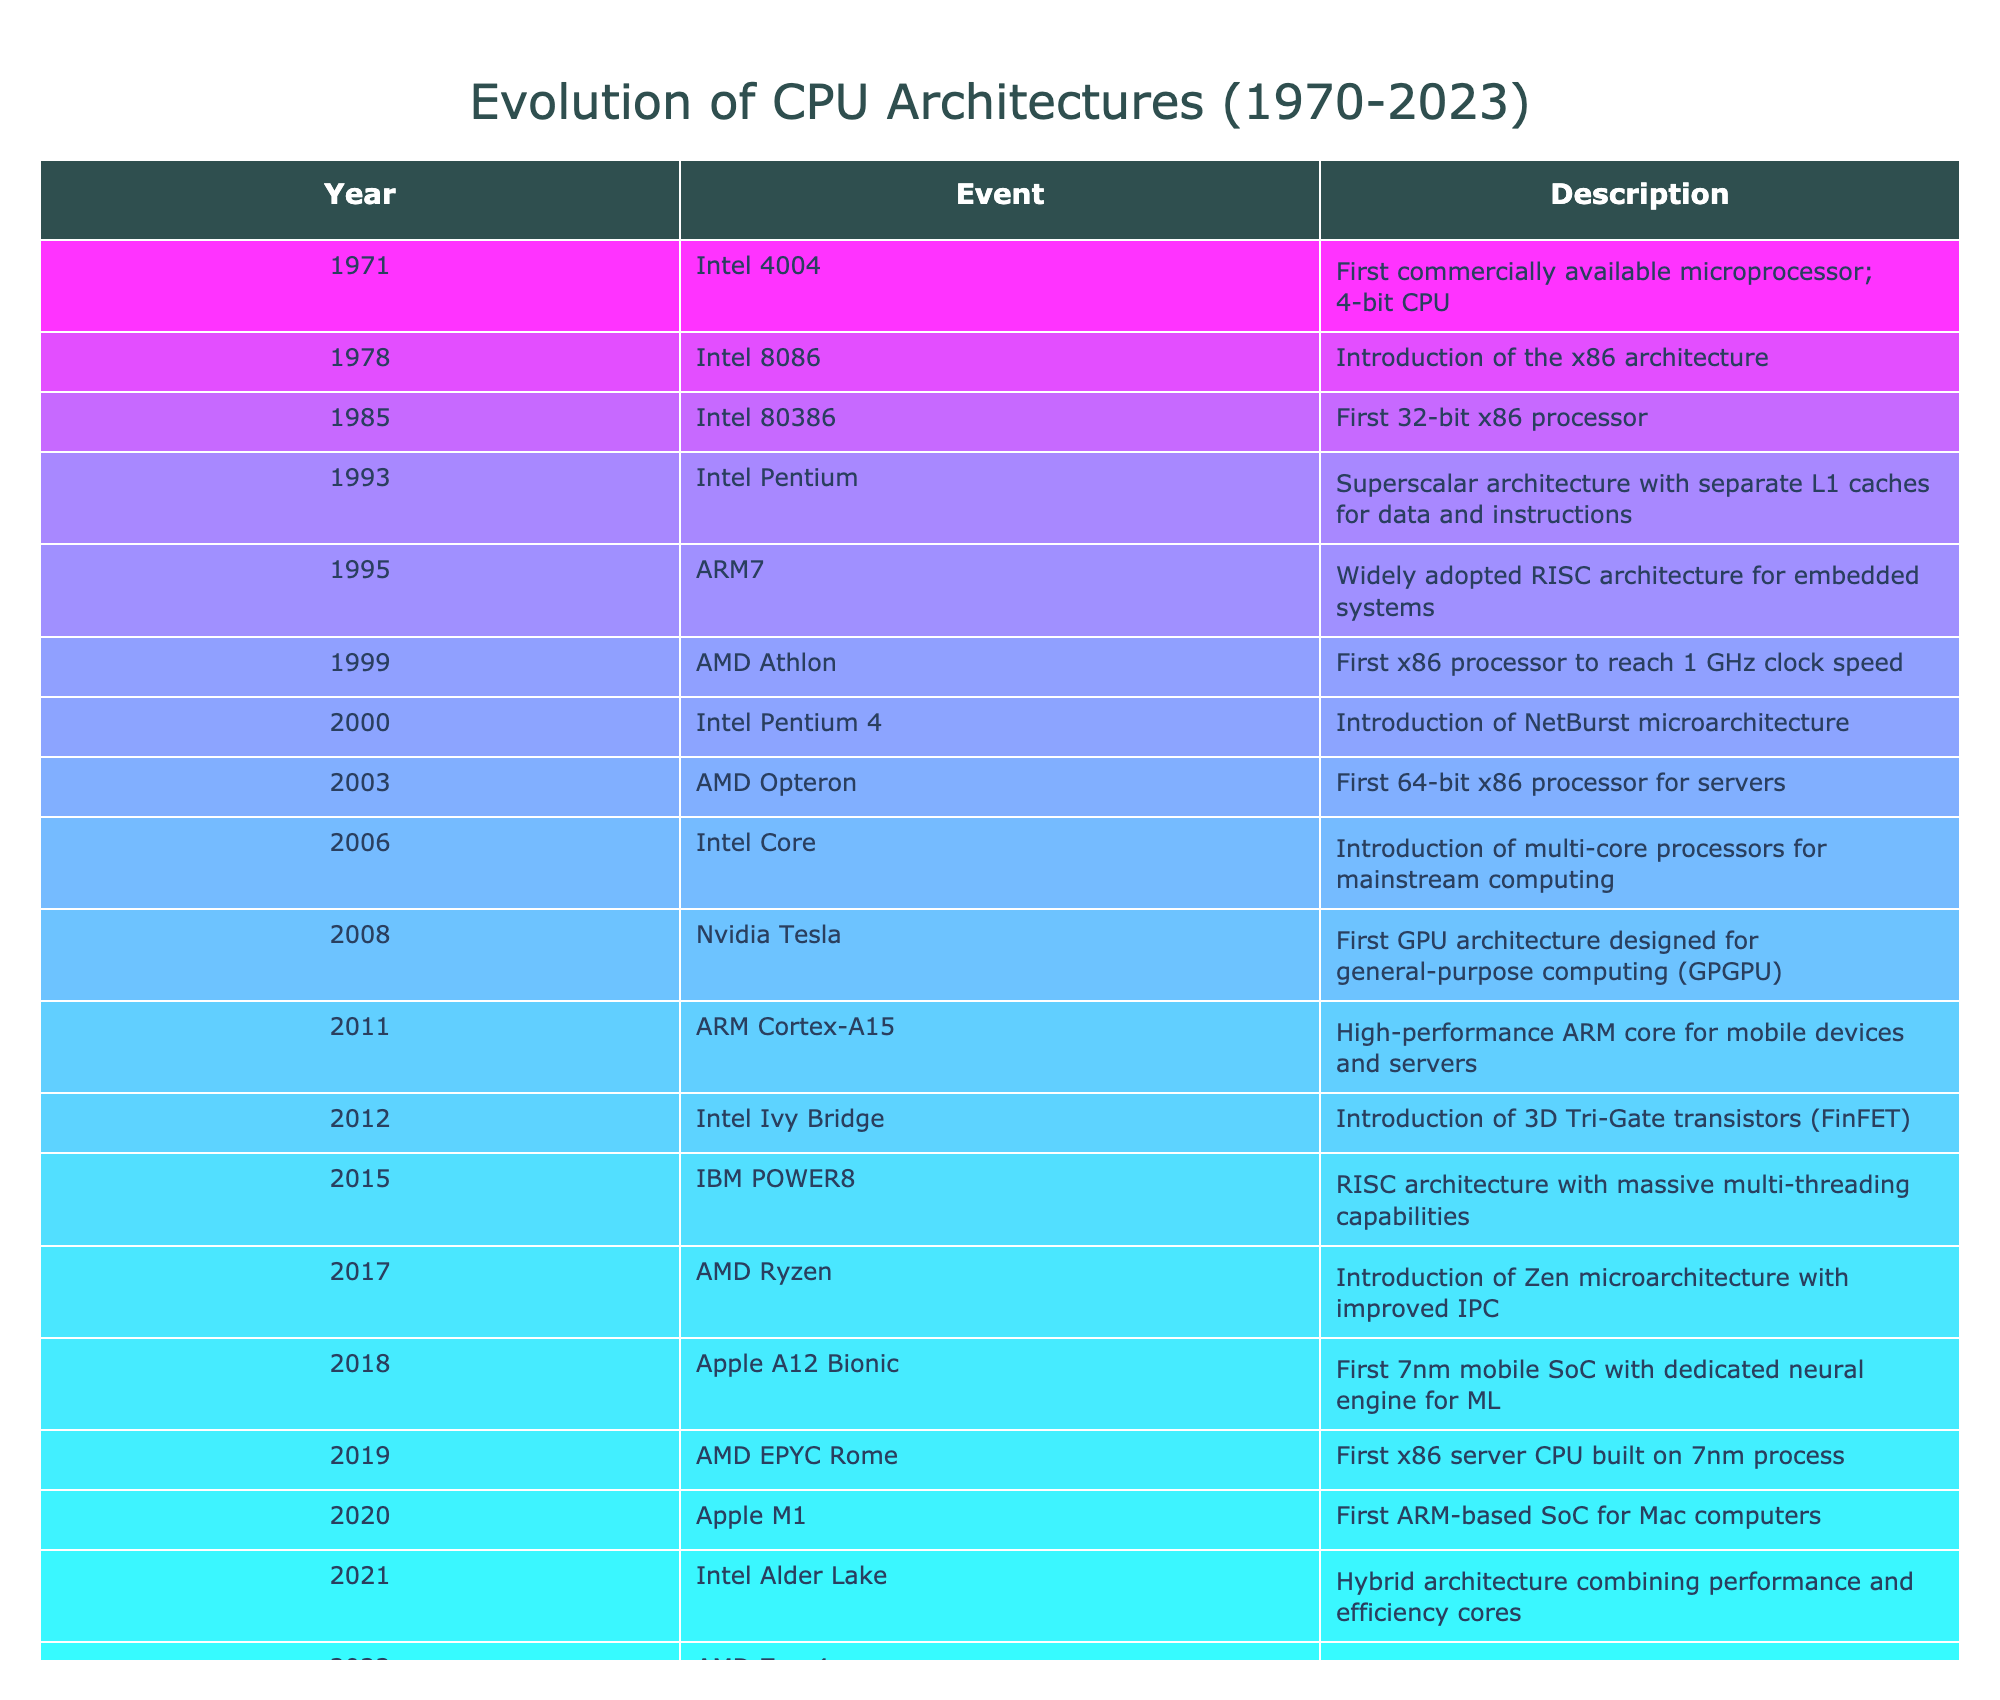What year was the Intel 4004 released? The Intel 4004 is listed in the table under the "Event" column with the "Year" column indicating it was released in 1971.
Answer: 1971 What is the significance of the AMD Athlon introduced in 1999? The AMD Athlon is noted in the table as the first x86 processor to reach a 1 GHz clock speed, highlighting its importance in CPU performance history.
Answer: First x86 processor to reach 1 GHz clock speed How many years are there between the introduction of the Intel Pentium and the AMD Ryzen? The Intel Pentium was introduced in 1993 and AMD Ryzen in 2017. The difference is 2017 - 1993 = 24 years.
Answer: 24 years Did the introduction of the Intel Core in 2006 mark the era of multi-core processors? Yes, according to the table, the Intel Core introduced in 2006 is specifically marked as the introduction of multi-core processors for mainstream computing.
Answer: Yes Which CPU architecture was first to use 3D Tri-Gate transistors and in what year? The table states that the Intel Ivy Bridge used 3D Tri-Gate transistors and was introduced in 2012.
Answer: Intel Ivy Bridge in 2012 How many years passed between the introduction of the first 32-bit x86 processor (Intel 80386) and the AMD EPYC Rome? The Intel 80386 was introduced in 1985, and the AMD EPYC Rome was introduced in 2019, giving a difference of 2019 - 1985 = 34 years.
Answer: 34 years When was the first ARM-based SoC for Mac computers introduced? The table indicates that the Apple M1, the first ARM-based SoC for Mac computers, was introduced in 2020.
Answer: 2020 Which two architectures were introduced in 2011? The table shows that the ARM Cortex-A15 and the Nvidia Tesla were both introduced in 2011.
Answer: ARM Cortex-A15 and Nvidia Tesla What is the relationship between the timeline of CPU architectures and advancements in manufacturing processes? Analyzing the table reveals that many significant advancements, such as the introduction of smaller process nodes (like 7nm for AMD EPYC Rome in 2019 and Apple M2 Ultra in 2023), correlate with the introduction of new architectures and improved performance. This demonstrates a trend where technological advancements in manufacturing processes have enabled the development of more efficient and powerful CPU architectures.
Answer: Advancements in manufacturing correlate with performance improvements in CPU architectures 